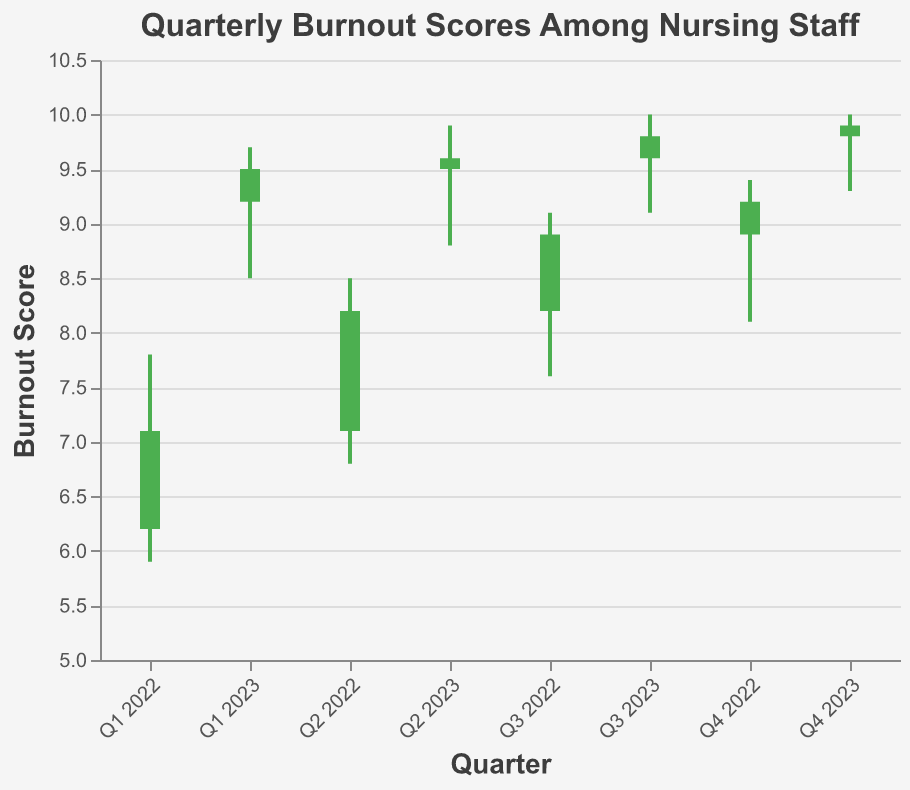what is the title of the figure? The title of the figure is located at the top and it provides a summary of what the figure represents. The text of the title is "Quarterly Burnout Scores Among Nursing Staff".
Answer: Quarterly Burnout Scores Among Nursing Staff How many quarters are represented in the figure? The x-axis of the figure represents the quarters and there are intervals from Q1 2022 to Q4 2023. Counting these gives us eight quarters.
Answer: 8 During which quarter did the burnout score have the highest high value? By examining the high values, the highest high value is 10.0 which occurs in Q3 2023 and Q4 2023.
Answer: Q3 2023 and Q4 2023 Which quarter has the largest difference between high and low burnout scores? To determine this, we need to find the difference between high and low values for each quarter. Q1 2022: 7.8 - 5.9 = 1.9, Q2 2022: 8.5 - 6.8 = 1.7, Q3 2022: 9.1 - 7.6 = 1.5, Q4 2022: 9.4 - 8.1 = 1.3, Q1 2023: 9.7 - 8.5 = 1.2, Q2 2023: 9.9 - 8.8 = 1.1, Q3 2023: 10.0 - 9.1 = 0.9, Q4 2023: 10.0 - 9.3 = 0.7. The largest difference is 1.9 in Q1 2022.
Answer: Q1 2022 In which quarters did the burnout score increase by comparing the open and close values? By comparing the open and close values, the quarters where the close value is higher than the open value are Q1 2022 (6.2 -> 7.1), Q2 2022 (7.1 -> 8.2), Q3 2022 (8.2 -> 8.9), Q4 2022 (8.9 -> 9.2), Q1 2023 (9.2 -> 9.5), Q2 2023 (9.5 -> 9.6), Q3 2023 (9.6 -> 9.8), Q4 2023 (9.8 -> 9.9).
Answer: All quarters What is the overall trend of the closing burnout scores from Q1 2022 to Q4 2023? To determine the trend, we examine the closing values at each quarter: Q1 2022: 7.1, Q2 2022: 8.2, Q3 2022: 8.9, Q4 2022: 9.2, Q1 2023: 9.5, Q2 2023: 9.6, Q3 2023: 9.8, Q4 2023: 9.9. There is a steady increase in the closing burnout scores.
Answer: Steadily increasing Which quarter had the lowest low burnout score? By looking at the low values across the quarters, the lowest value is 5.9 which occurs in Q1 2022.
Answer: Q1 2022 